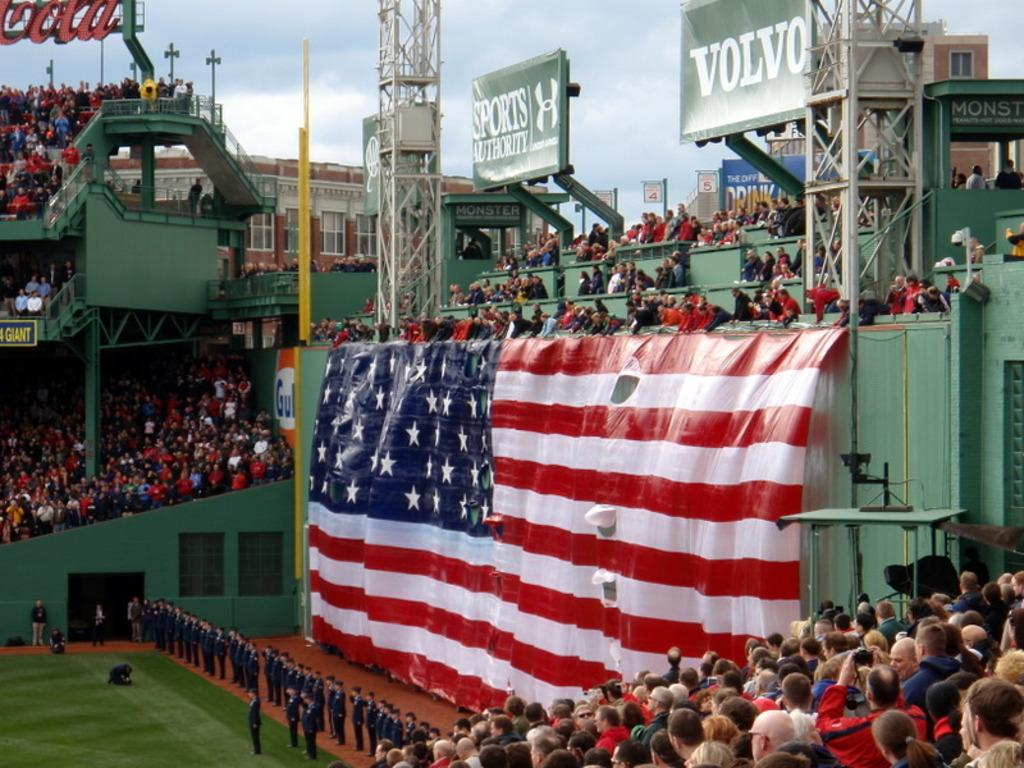<image>
Share a concise interpretation of the image provided. A large Volvo sign hangs over stadium seats and an American flag. 